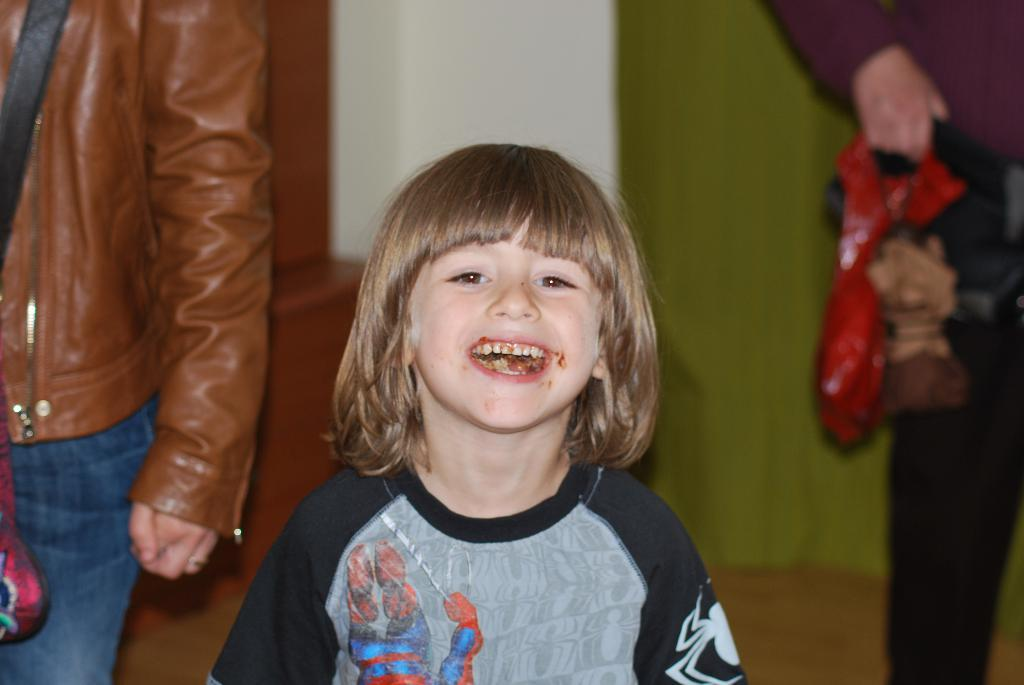Who is the main subject in the image? There is a girl in the center of the image. What is the girl doing in the image? The girl is standing and smiling. What can be seen in the background of the image? There are people, a wall, and a curtain in the background of the image. What color is the ink on the girl's hand in the image? There is no ink visible on the girl's hand in the image. How does the girl feel about the situation in the image? The image only shows the girl's expression, which is a smile, but it does not provide information about her feelings or thoughts. 